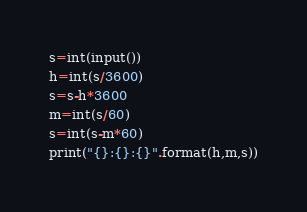Convert code to text. <code><loc_0><loc_0><loc_500><loc_500><_Python_>s=int(input())
h=int(s/3600)
s=s-h*3600
m=int(s/60)
s=int(s-m*60)
print("{}:{}:{}".format(h,m,s))
</code> 